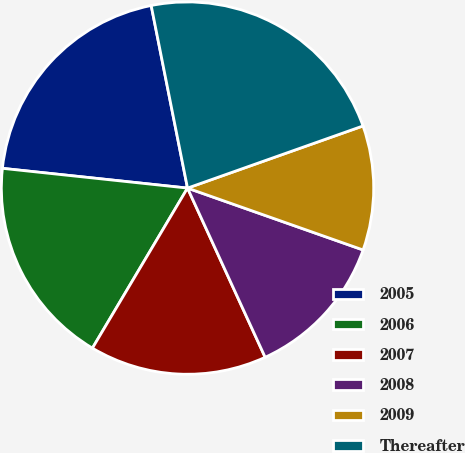<chart> <loc_0><loc_0><loc_500><loc_500><pie_chart><fcel>2005<fcel>2006<fcel>2007<fcel>2008<fcel>2009<fcel>Thereafter<nl><fcel>20.18%<fcel>18.16%<fcel>15.38%<fcel>12.76%<fcel>10.81%<fcel>22.71%<nl></chart> 